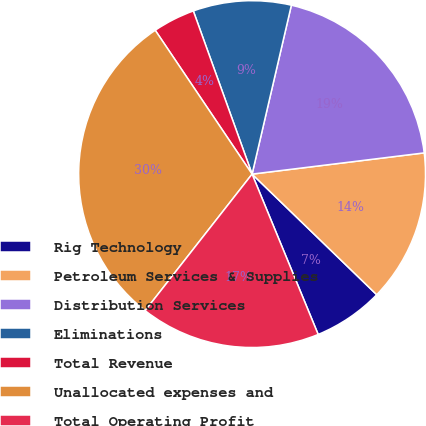Convert chart to OTSL. <chart><loc_0><loc_0><loc_500><loc_500><pie_chart><fcel>Rig Technology<fcel>Petroleum Services & Supplies<fcel>Distribution Services<fcel>Eliminations<fcel>Total Revenue<fcel>Unallocated expenses and<fcel>Total Operating Profit<nl><fcel>6.54%<fcel>14.19%<fcel>19.41%<fcel>9.14%<fcel>3.93%<fcel>29.99%<fcel>16.8%<nl></chart> 